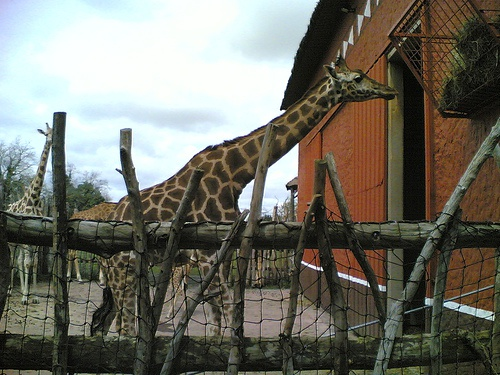Describe the objects in this image and their specific colors. I can see giraffe in lavender, black, and gray tones, giraffe in lavender, gray, black, darkgray, and darkgreen tones, and giraffe in lavender, olive, and gray tones in this image. 